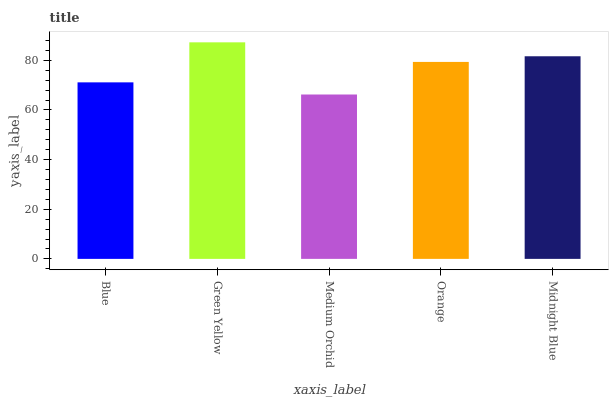Is Medium Orchid the minimum?
Answer yes or no. Yes. Is Green Yellow the maximum?
Answer yes or no. Yes. Is Green Yellow the minimum?
Answer yes or no. No. Is Medium Orchid the maximum?
Answer yes or no. No. Is Green Yellow greater than Medium Orchid?
Answer yes or no. Yes. Is Medium Orchid less than Green Yellow?
Answer yes or no. Yes. Is Medium Orchid greater than Green Yellow?
Answer yes or no. No. Is Green Yellow less than Medium Orchid?
Answer yes or no. No. Is Orange the high median?
Answer yes or no. Yes. Is Orange the low median?
Answer yes or no. Yes. Is Medium Orchid the high median?
Answer yes or no. No. Is Blue the low median?
Answer yes or no. No. 